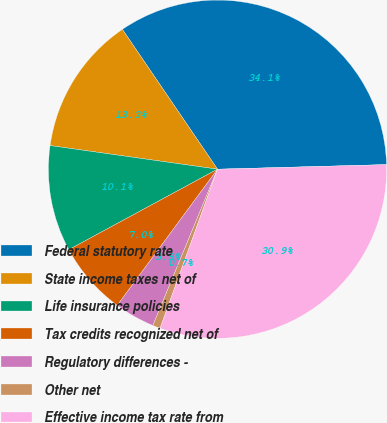<chart> <loc_0><loc_0><loc_500><loc_500><pie_chart><fcel>Federal statutory rate<fcel>State income taxes net of<fcel>Life insurance policies<fcel>Tax credits recognized net of<fcel>Regulatory differences -<fcel>Other net<fcel>Effective income tax rate from<nl><fcel>34.08%<fcel>13.26%<fcel>10.13%<fcel>7.0%<fcel>3.86%<fcel>0.73%<fcel>30.95%<nl></chart> 